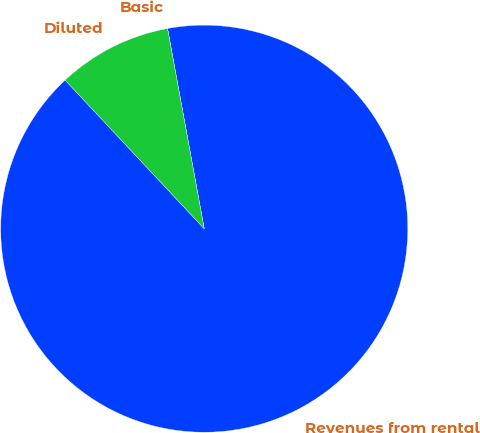Convert chart. <chart><loc_0><loc_0><loc_500><loc_500><pie_chart><fcel>Revenues from rental<fcel>Basic<fcel>Diluted<nl><fcel>90.91%<fcel>0.0%<fcel>9.09%<nl></chart> 